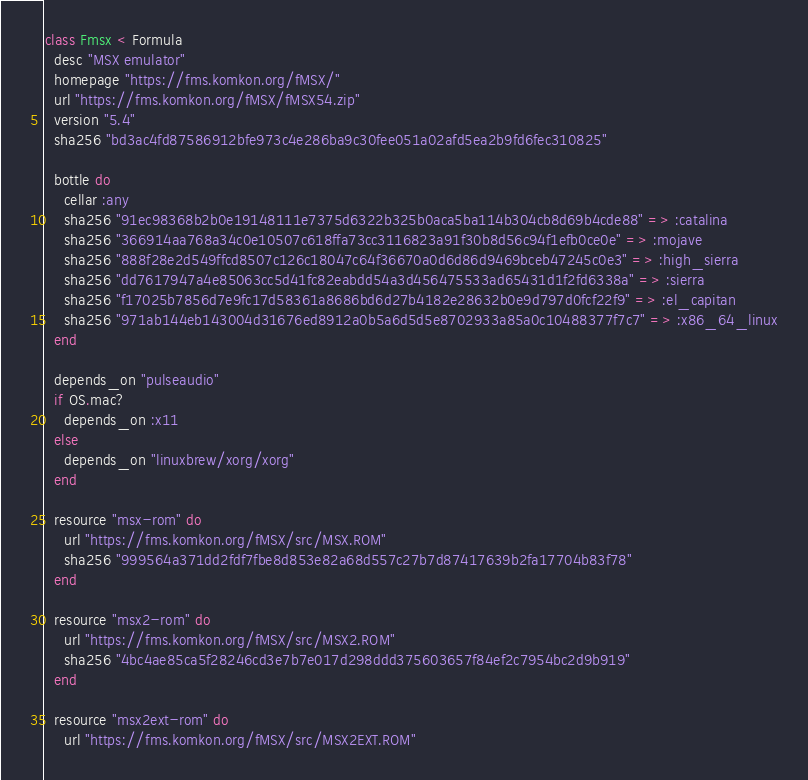Convert code to text. <code><loc_0><loc_0><loc_500><loc_500><_Ruby_>class Fmsx < Formula
  desc "MSX emulator"
  homepage "https://fms.komkon.org/fMSX/"
  url "https://fms.komkon.org/fMSX/fMSX54.zip"
  version "5.4"
  sha256 "bd3ac4fd87586912bfe973c4e286ba9c30fee051a02afd5ea2b9fd6fec310825"

  bottle do
    cellar :any
    sha256 "91ec98368b2b0e19148111e7375d6322b325b0aca5ba114b304cb8d69b4cde88" => :catalina
    sha256 "366914aa768a34c0e10507c618ffa73cc3116823a91f30b8d56c94f1efb0ce0e" => :mojave
    sha256 "888f28e2d549ffcd8507c126c18047c64f36670a0d6d86d9469bceb47245c0e3" => :high_sierra
    sha256 "dd7617947a4e85063cc5d41fc82eabdd54a3d456475533ad65431d1f2fd6338a" => :sierra
    sha256 "f17025b7856d7e9fc17d58361a8686bd6d27b4182e28632b0e9d797d0fcf22f9" => :el_capitan
    sha256 "971ab144eb143004d31676ed8912a0b5a6d5d5e8702933a85a0c10488377f7c7" => :x86_64_linux
  end

  depends_on "pulseaudio"
  if OS.mac?
    depends_on :x11
  else
    depends_on "linuxbrew/xorg/xorg"
  end

  resource "msx-rom" do
    url "https://fms.komkon.org/fMSX/src/MSX.ROM"
    sha256 "999564a371dd2fdf7fbe8d853e82a68d557c27b7d87417639b2fa17704b83f78"
  end

  resource "msx2-rom" do
    url "https://fms.komkon.org/fMSX/src/MSX2.ROM"
    sha256 "4bc4ae85ca5f28246cd3e7b7e017d298ddd375603657f84ef2c7954bc2d9b919"
  end

  resource "msx2ext-rom" do
    url "https://fms.komkon.org/fMSX/src/MSX2EXT.ROM"</code> 